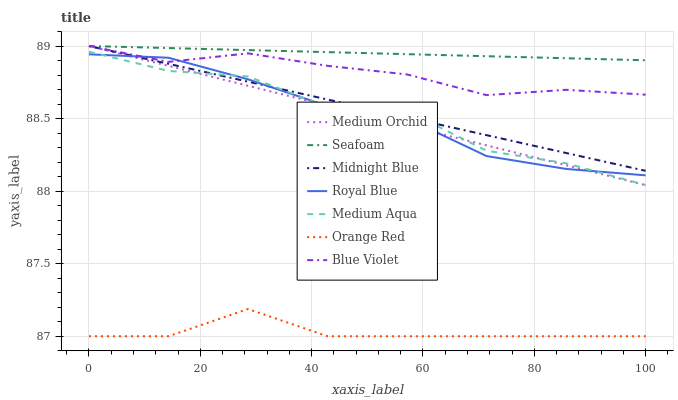Does Orange Red have the minimum area under the curve?
Answer yes or no. Yes. Does Seafoam have the maximum area under the curve?
Answer yes or no. Yes. Does Medium Orchid have the minimum area under the curve?
Answer yes or no. No. Does Medium Orchid have the maximum area under the curve?
Answer yes or no. No. Is Seafoam the smoothest?
Answer yes or no. Yes. Is Medium Aqua the roughest?
Answer yes or no. Yes. Is Medium Orchid the smoothest?
Answer yes or no. No. Is Medium Orchid the roughest?
Answer yes or no. No. Does Medium Orchid have the lowest value?
Answer yes or no. No. Does Blue Violet have the highest value?
Answer yes or no. Yes. Does Royal Blue have the highest value?
Answer yes or no. No. Is Medium Aqua less than Blue Violet?
Answer yes or no. Yes. Is Medium Aqua greater than Orange Red?
Answer yes or no. Yes. Does Medium Orchid intersect Blue Violet?
Answer yes or no. Yes. Is Medium Orchid less than Blue Violet?
Answer yes or no. No. Is Medium Orchid greater than Blue Violet?
Answer yes or no. No. Does Medium Aqua intersect Blue Violet?
Answer yes or no. No. 